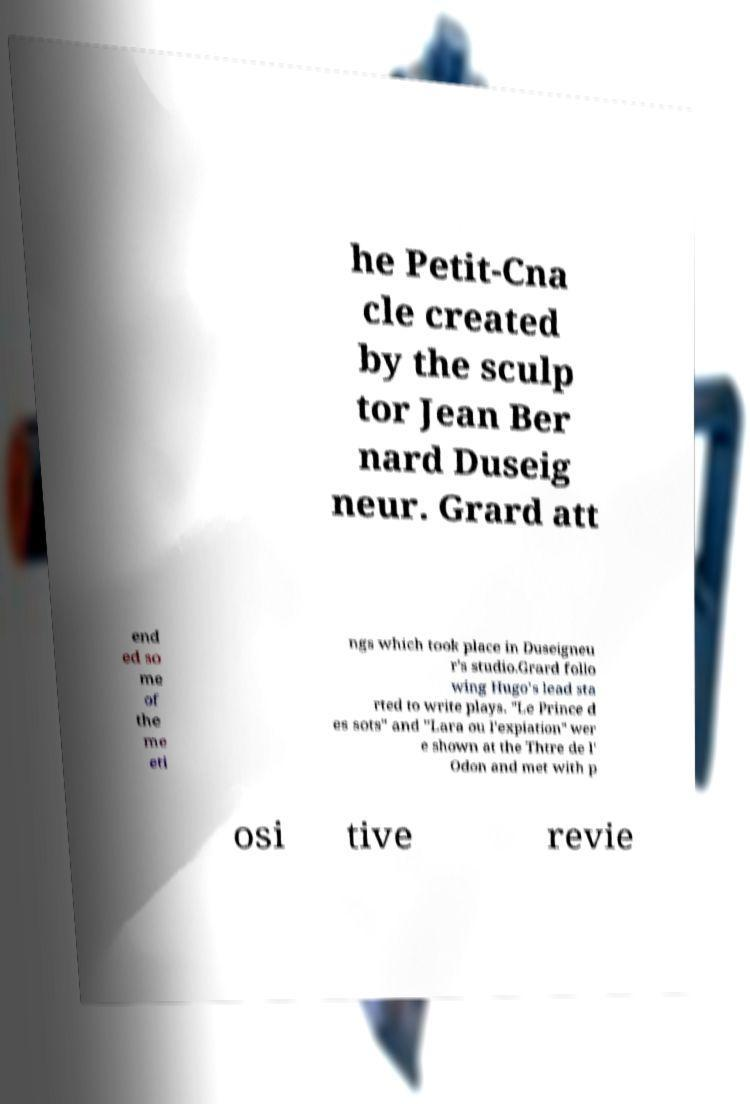Please read and relay the text visible in this image. What does it say? he Petit-Cna cle created by the sculp tor Jean Ber nard Duseig neur. Grard att end ed so me of the me eti ngs which took place in Duseigneu r's studio.Grard follo wing Hugo's lead sta rted to write plays. "Le Prince d es sots" and "Lara ou l'expiation" wer e shown at the Thtre de l' Odon and met with p osi tive revie 